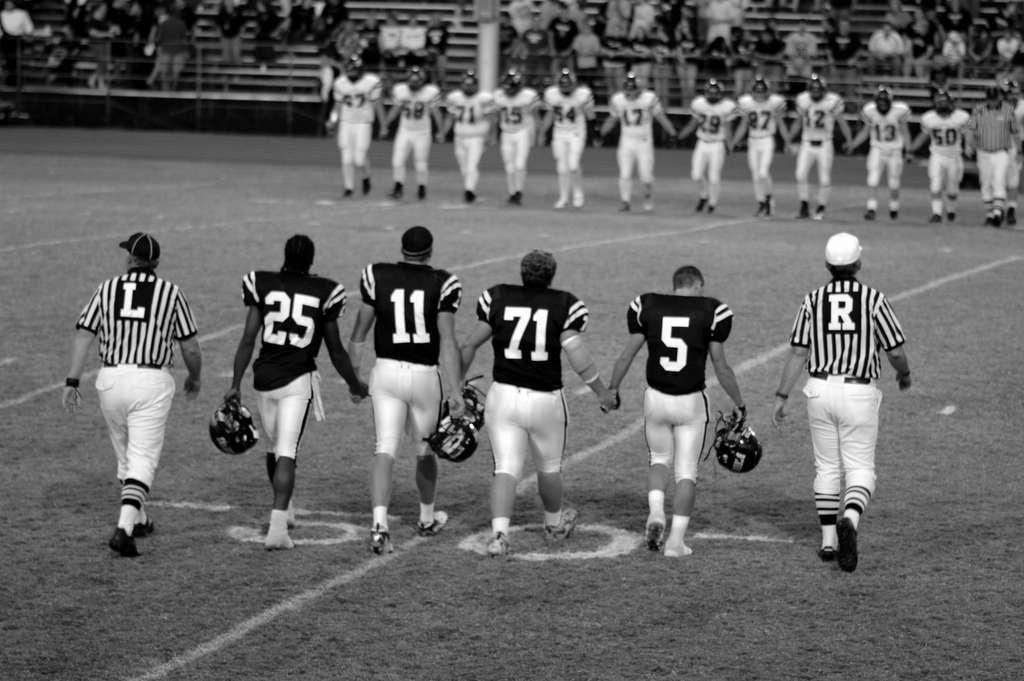<image>
Summarize the visual content of the image. Football players and referees walk at the 50 yard line. 